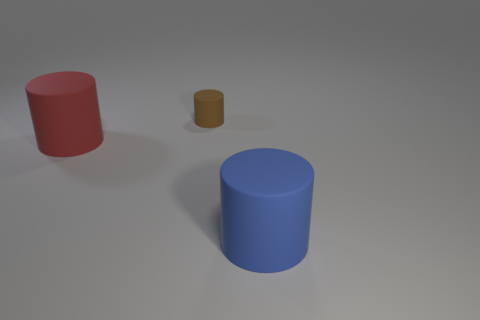Add 1 tiny brown metallic cylinders. How many objects exist? 4 Subtract all large cylinders. How many cylinders are left? 1 Add 2 brown metal objects. How many brown metal objects exist? 2 Subtract 0 green blocks. How many objects are left? 3 Subtract 2 cylinders. How many cylinders are left? 1 Subtract all blue cylinders. Subtract all blue spheres. How many cylinders are left? 2 Subtract all blue balls. How many brown cylinders are left? 1 Subtract all big blue rubber cylinders. Subtract all big things. How many objects are left? 0 Add 1 large cylinders. How many large cylinders are left? 3 